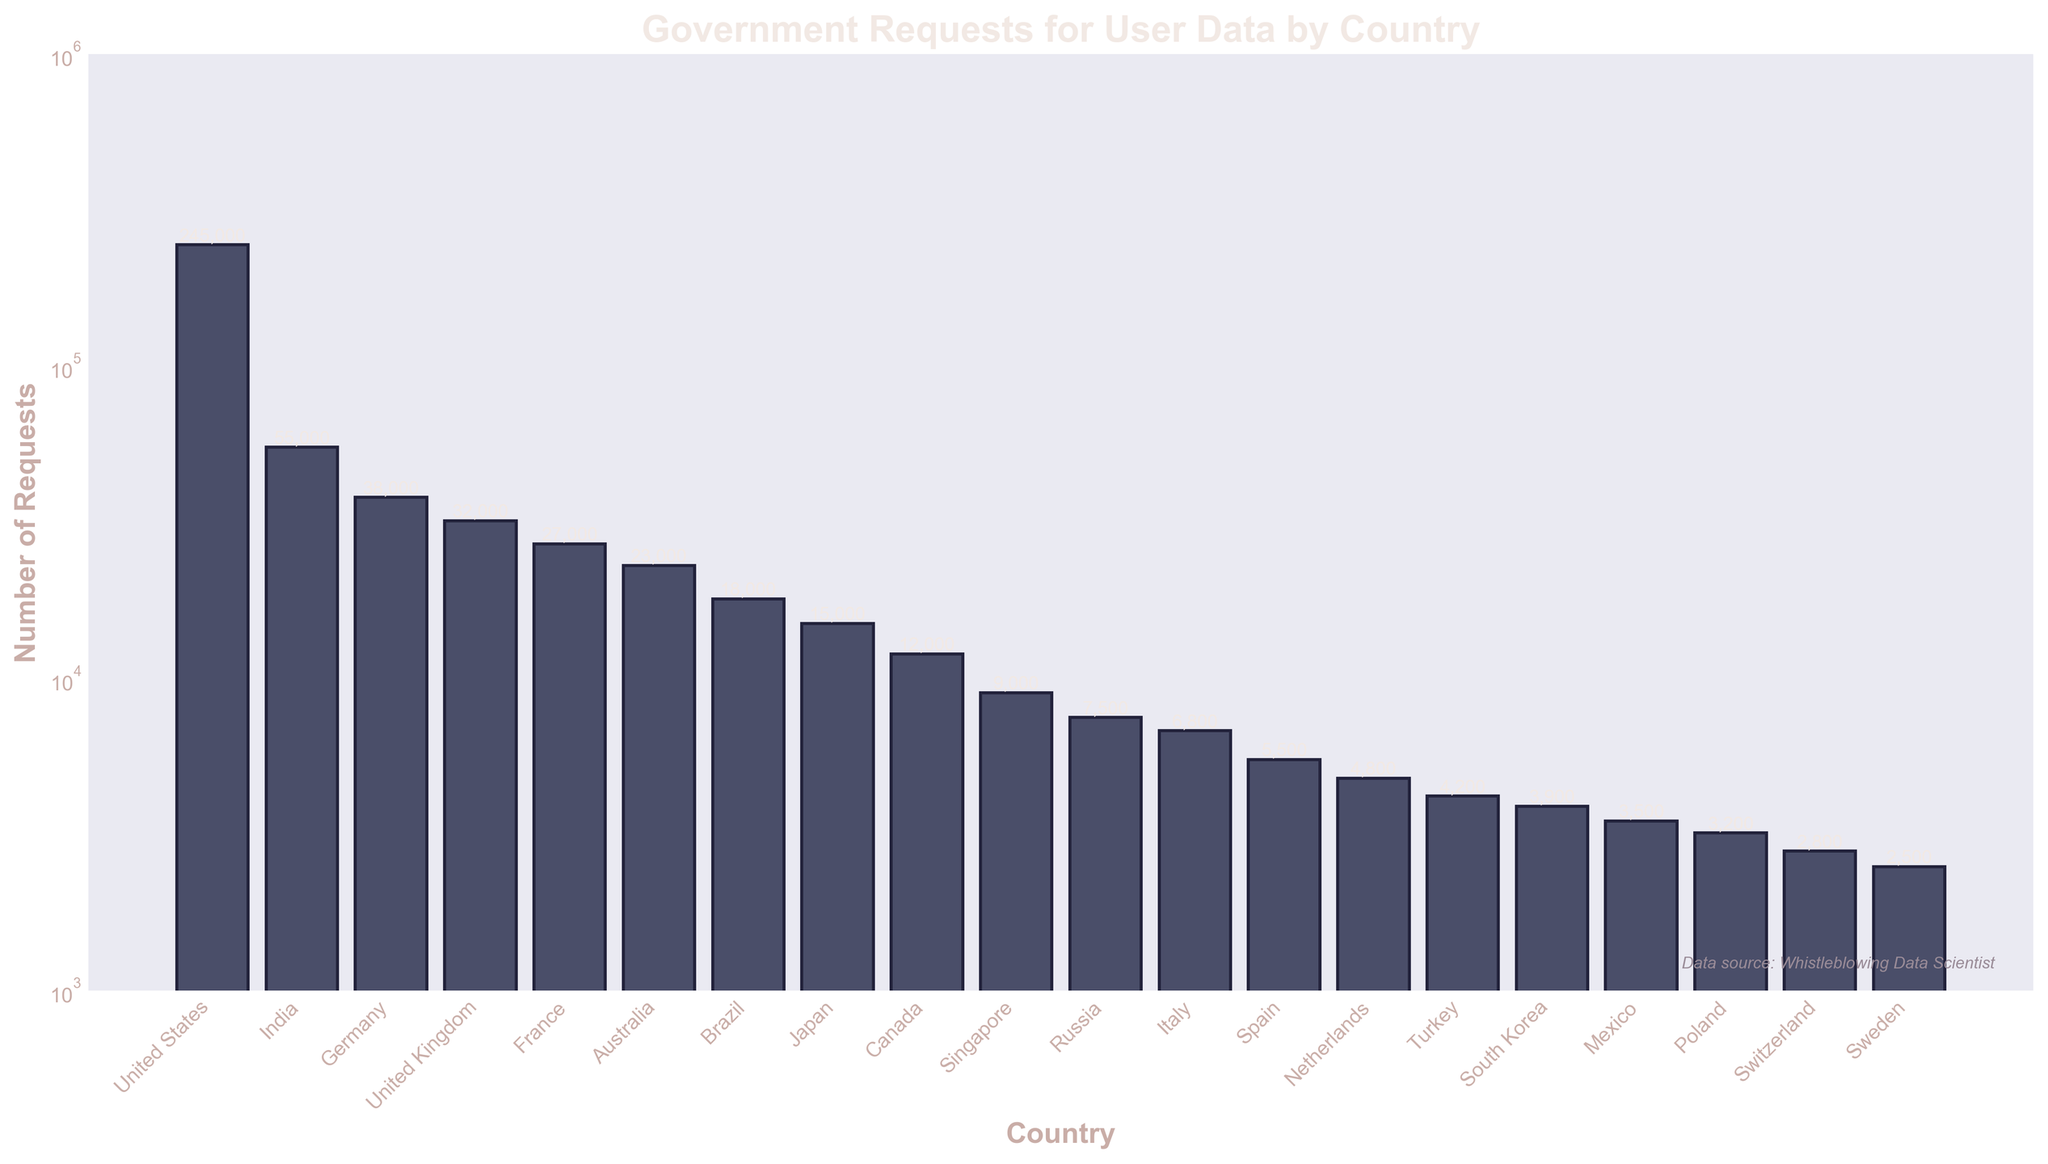Which country has the highest number of government requests for user data? The United States has the tallest bar on the plot, indicating it has the highest number of requests.
Answer: The United States How many government requests for user data did India receive? The bar corresponding to India is labeled with "55,000", representing the number of requests.
Answer: 55,000 Which has more government requests, Germany or France? Germany's bar is taller and labeled with "38,000" compared to France's "27,000".
Answer: Germany What's the sum of government requests for user data from Australia and Canada? The bars for Australia and Canada are labeled with "23,000" and "12,000" respectively. Adding these gives 23,000 + 12,000.
Answer: 35,000 Which country has the least number of government requests for user data? The smallest bar on the plot is labeled for Sweden with "2,500".
Answer: Sweden What is the approximate difference in government requests for user data between Japan and Russia? Japan's bar shows "15,000" and Russia's bar shows "7,500". The difference is approximately 15,000 - 7,500.
Answer: 7,500 How do the government requests for the United Kingdom compare to those of Brazil? The bar for the United Kingdom reads "32,000" while Brazil's bar reads "18,000". The United Kingdom has more requests.
Answer: The United Kingdom What visual attribute is used to indicate the number of government requests in the bar chart? The height of each bar represents the number of government requests, with taller bars indicating higher numbers.
Answer: Bar height What is the median number of government requests in the dataset? To find the median, the countries are ordered by request counts: [2500, 2800, 3200, 3500, 3900, 4200, 4800, 5500, 6800, 7500, 9000, 12000, 15000, 18000, 23000, 27000, 32000, 38000, 55000, 245000]. With 20 countries, the median is the average of the 10th (7,500) and 11th (9,000) values.
Answer: 8,250 How many more government requests are there in the United States than in the United Kingdom? The United States has 245,000 requests and the United Kingdom has 32,000. The difference is 245,000 - 32,000.
Answer: 213,000 